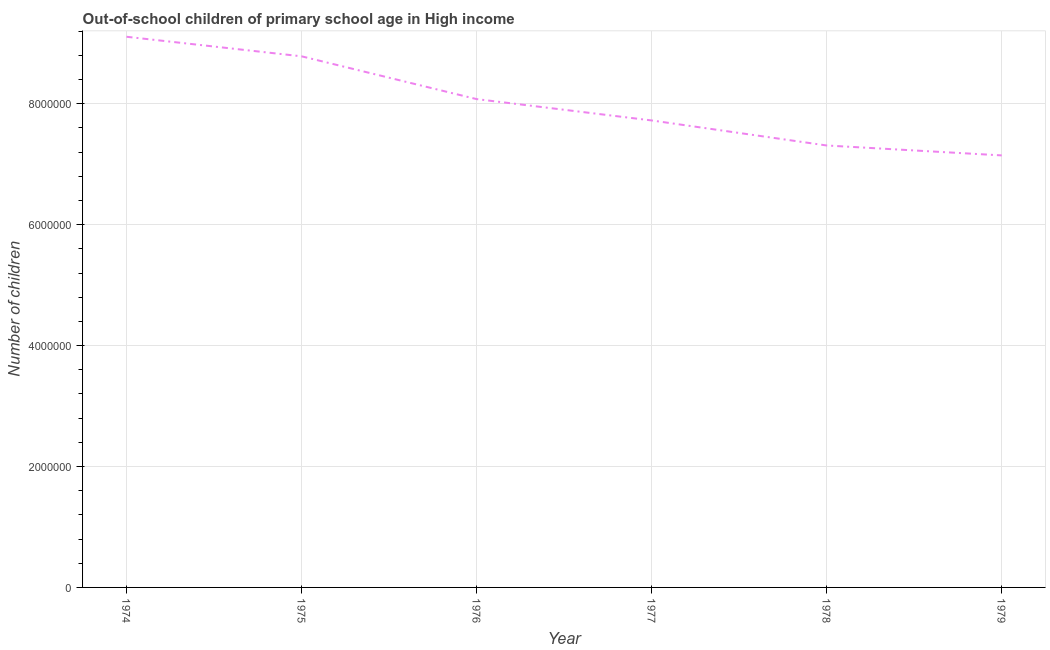What is the number of out-of-school children in 1978?
Offer a terse response. 7.31e+06. Across all years, what is the maximum number of out-of-school children?
Ensure brevity in your answer.  9.11e+06. Across all years, what is the minimum number of out-of-school children?
Keep it short and to the point. 7.15e+06. In which year was the number of out-of-school children maximum?
Give a very brief answer. 1974. In which year was the number of out-of-school children minimum?
Offer a very short reply. 1979. What is the sum of the number of out-of-school children?
Provide a succinct answer. 4.81e+07. What is the difference between the number of out-of-school children in 1974 and 1976?
Your answer should be very brief. 1.03e+06. What is the average number of out-of-school children per year?
Give a very brief answer. 8.02e+06. What is the median number of out-of-school children?
Keep it short and to the point. 7.90e+06. Do a majority of the years between 1975 and 1977 (inclusive) have number of out-of-school children greater than 7600000 ?
Your answer should be very brief. Yes. What is the ratio of the number of out-of-school children in 1975 to that in 1978?
Ensure brevity in your answer.  1.2. Is the number of out-of-school children in 1977 less than that in 1979?
Your answer should be compact. No. What is the difference between the highest and the second highest number of out-of-school children?
Make the answer very short. 3.23e+05. Is the sum of the number of out-of-school children in 1974 and 1978 greater than the maximum number of out-of-school children across all years?
Give a very brief answer. Yes. What is the difference between the highest and the lowest number of out-of-school children?
Ensure brevity in your answer.  1.96e+06. How many lines are there?
Give a very brief answer. 1. How many years are there in the graph?
Offer a very short reply. 6. What is the difference between two consecutive major ticks on the Y-axis?
Make the answer very short. 2.00e+06. Does the graph contain any zero values?
Ensure brevity in your answer.  No. Does the graph contain grids?
Your answer should be compact. Yes. What is the title of the graph?
Your answer should be compact. Out-of-school children of primary school age in High income. What is the label or title of the X-axis?
Your answer should be compact. Year. What is the label or title of the Y-axis?
Provide a succinct answer. Number of children. What is the Number of children of 1974?
Offer a terse response. 9.11e+06. What is the Number of children in 1975?
Offer a terse response. 8.78e+06. What is the Number of children of 1976?
Provide a short and direct response. 8.08e+06. What is the Number of children in 1977?
Provide a short and direct response. 7.72e+06. What is the Number of children in 1978?
Offer a very short reply. 7.31e+06. What is the Number of children in 1979?
Ensure brevity in your answer.  7.15e+06. What is the difference between the Number of children in 1974 and 1975?
Your response must be concise. 3.23e+05. What is the difference between the Number of children in 1974 and 1976?
Keep it short and to the point. 1.03e+06. What is the difference between the Number of children in 1974 and 1977?
Ensure brevity in your answer.  1.38e+06. What is the difference between the Number of children in 1974 and 1978?
Provide a succinct answer. 1.80e+06. What is the difference between the Number of children in 1974 and 1979?
Your answer should be very brief. 1.96e+06. What is the difference between the Number of children in 1975 and 1976?
Ensure brevity in your answer.  7.08e+05. What is the difference between the Number of children in 1975 and 1977?
Offer a very short reply. 1.06e+06. What is the difference between the Number of children in 1975 and 1978?
Your answer should be very brief. 1.47e+06. What is the difference between the Number of children in 1975 and 1979?
Provide a succinct answer. 1.64e+06. What is the difference between the Number of children in 1976 and 1977?
Keep it short and to the point. 3.53e+05. What is the difference between the Number of children in 1976 and 1978?
Your answer should be compact. 7.67e+05. What is the difference between the Number of children in 1976 and 1979?
Keep it short and to the point. 9.31e+05. What is the difference between the Number of children in 1977 and 1978?
Offer a very short reply. 4.14e+05. What is the difference between the Number of children in 1977 and 1979?
Your answer should be compact. 5.78e+05. What is the difference between the Number of children in 1978 and 1979?
Your answer should be very brief. 1.64e+05. What is the ratio of the Number of children in 1974 to that in 1976?
Keep it short and to the point. 1.13. What is the ratio of the Number of children in 1974 to that in 1977?
Make the answer very short. 1.18. What is the ratio of the Number of children in 1974 to that in 1978?
Ensure brevity in your answer.  1.25. What is the ratio of the Number of children in 1974 to that in 1979?
Keep it short and to the point. 1.27. What is the ratio of the Number of children in 1975 to that in 1976?
Your answer should be compact. 1.09. What is the ratio of the Number of children in 1975 to that in 1977?
Provide a short and direct response. 1.14. What is the ratio of the Number of children in 1975 to that in 1978?
Offer a terse response. 1.2. What is the ratio of the Number of children in 1975 to that in 1979?
Keep it short and to the point. 1.23. What is the ratio of the Number of children in 1976 to that in 1977?
Provide a succinct answer. 1.05. What is the ratio of the Number of children in 1976 to that in 1978?
Your response must be concise. 1.1. What is the ratio of the Number of children in 1976 to that in 1979?
Provide a short and direct response. 1.13. What is the ratio of the Number of children in 1977 to that in 1978?
Your response must be concise. 1.06. What is the ratio of the Number of children in 1977 to that in 1979?
Your answer should be compact. 1.08. 